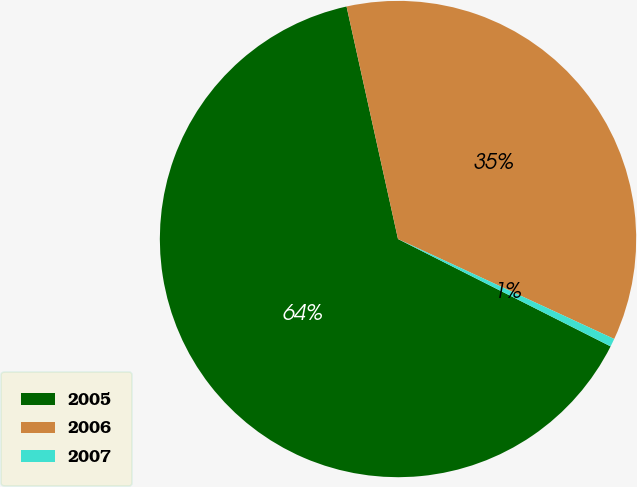Convert chart to OTSL. <chart><loc_0><loc_0><loc_500><loc_500><pie_chart><fcel>2005<fcel>2006<fcel>2007<nl><fcel>64.09%<fcel>35.36%<fcel>0.55%<nl></chart> 